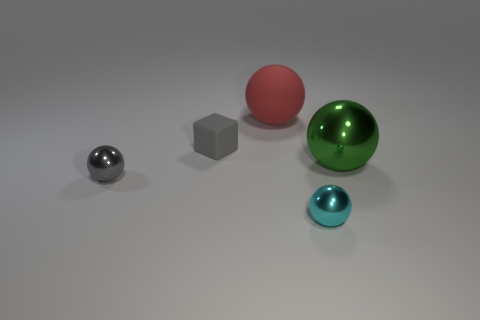Subtract all big green shiny spheres. How many spheres are left? 3 Add 1 red objects. How many objects exist? 6 Subtract all gray spheres. How many spheres are left? 3 Subtract 1 cubes. How many cubes are left? 0 Subtract all blocks. How many objects are left? 4 Add 2 large yellow spheres. How many large yellow spheres exist? 2 Subtract 0 brown spheres. How many objects are left? 5 Subtract all red spheres. Subtract all yellow cylinders. How many spheres are left? 3 Subtract all cyan cylinders. How many gray balls are left? 1 Subtract all green shiny balls. Subtract all gray rubber cubes. How many objects are left? 3 